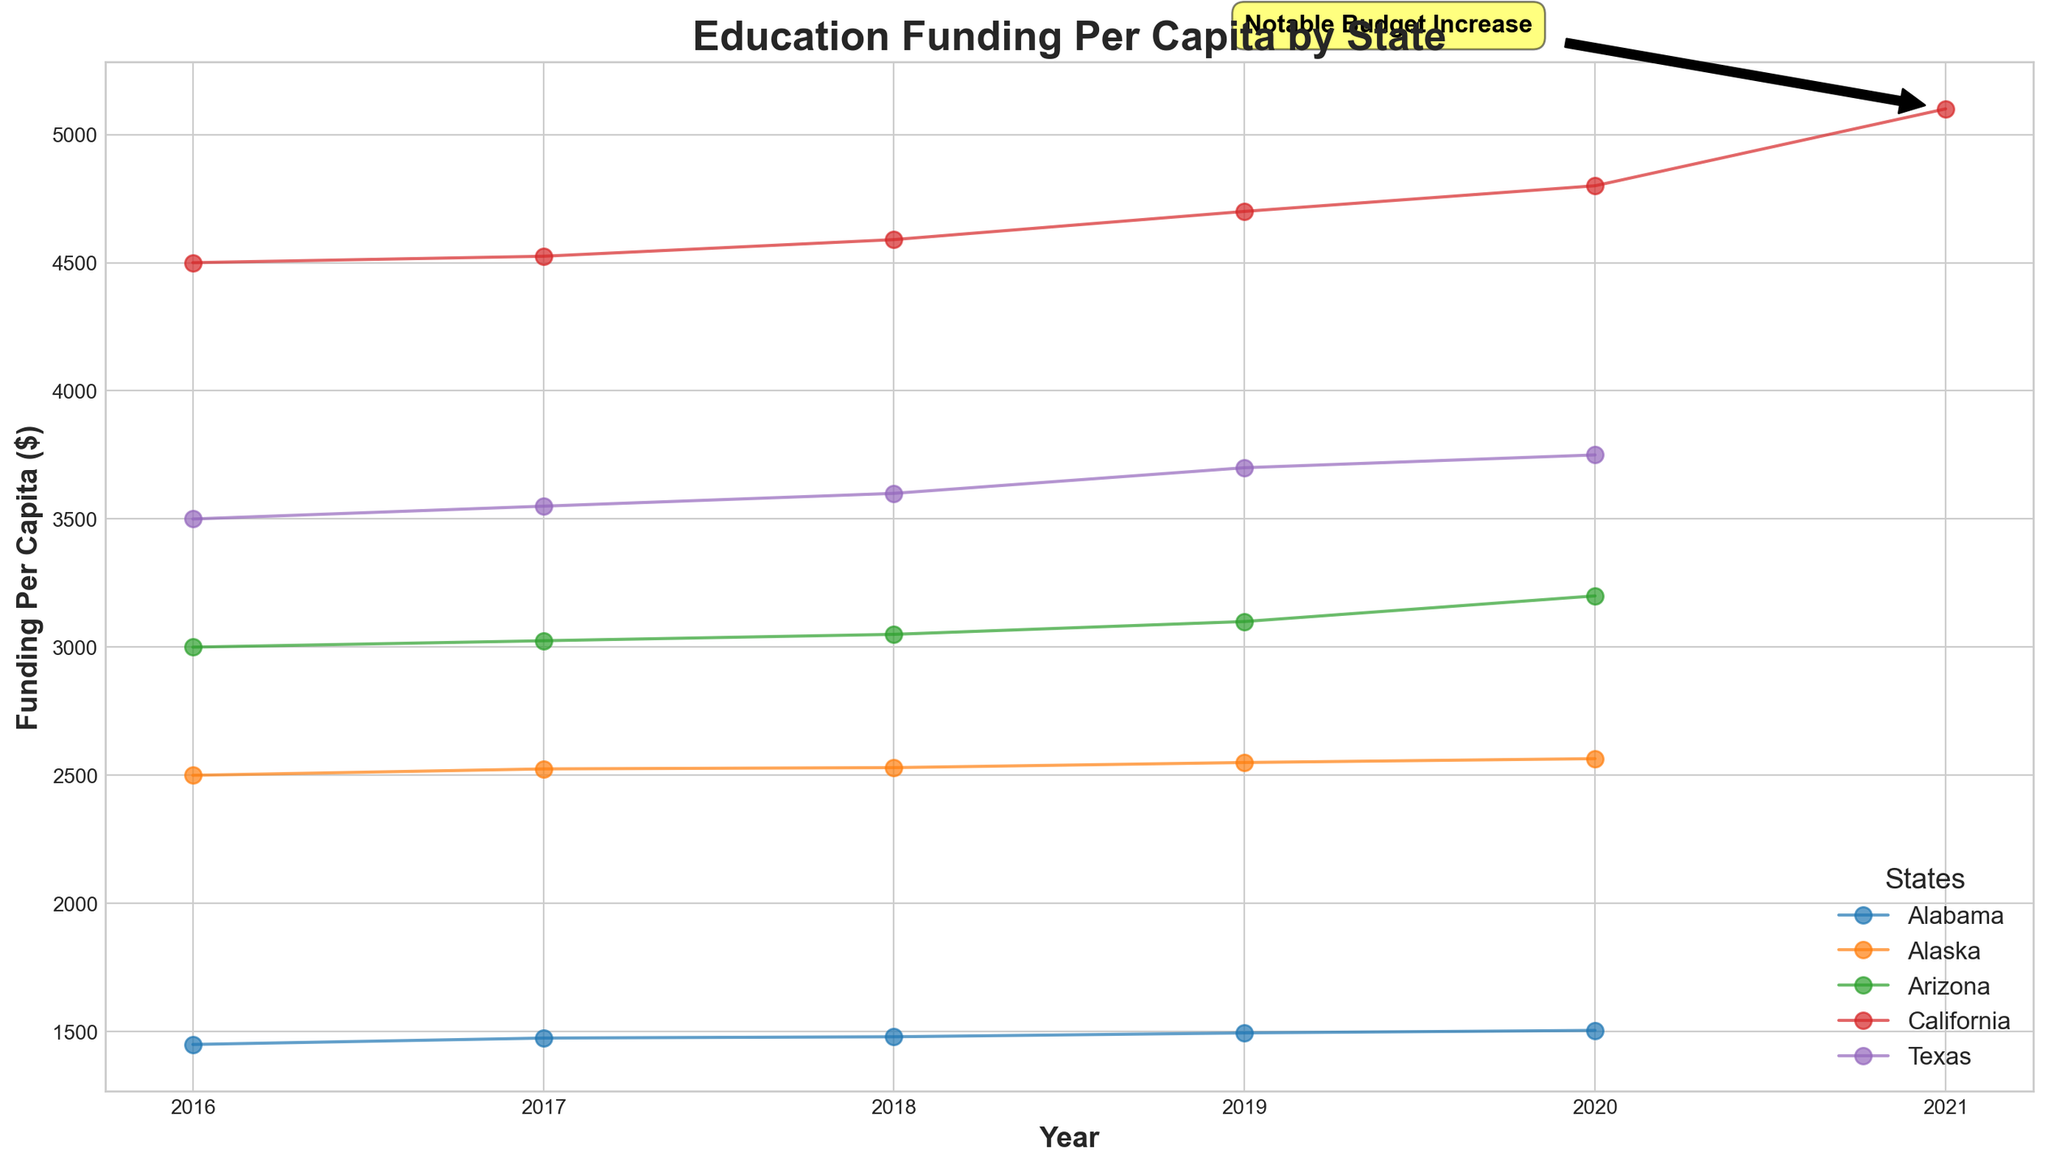Which state had the highest education funding per capita in 2020? By observing the chart, each state's funding levels can be identified for the year 2020. The plot shows that California had the highest funding per capita in 2020.
Answer: California Which state showed a notable budget increase, and in which year did it happen? The chart marks a notable budget increase with an annotation. The annotation is labeled "Notable Budget Increase" pointing to California in 2021.
Answer: California, 2021 Between 2016 and 2020, did Texas or Alabama have a higher increase in education funding per capita? We need to subtract the funding per capita in 2016 from that in 2020 for both states and compare the results. Texas: 3750 - 3500 = 250, Alabama: 1505 - 1450 = 55. Texas had a higher increase.
Answer: Texas How much more per capita did California spend on education in 2020 compared to Alaska? Find the funding values for both states in 2020 and calculate the difference: California (4800) - Alaska (2565) = 2235.
Answer: 2235 Which state had constant or minimal changes in education funding per capita between 2016 and 2020? Observing the plotted lines across the years, Alabama shows the smallest and most gradual increase in the figure, indicating minimal changes.
Answer: Alabama By how much did Arizona's education funding per capita increase from 2016 to 2020? Calculate the difference between the 2020 and 2016 funding values for Arizona: 3200 - 3000 = 200.
Answer: 200 What trend can be observed in the Education Funding Per Capita for California from 2016 to 2021? From 2016 to 2021, California's funding per capita shows an upward trend. In 2016, it starts at 4500, increasing each year, with a notable jump leading to 5100 in 2021.
Answer: Upward trend Which state experienced the largest increase between any two consecutive years, and what was the increase amount? Observing the slopes of the lines, California's increase sharply in 2021. The largest increase is from 2020 to 2021, where the value jumps from 4800 to 5100, an increase of 300.
Answer: California, 300 